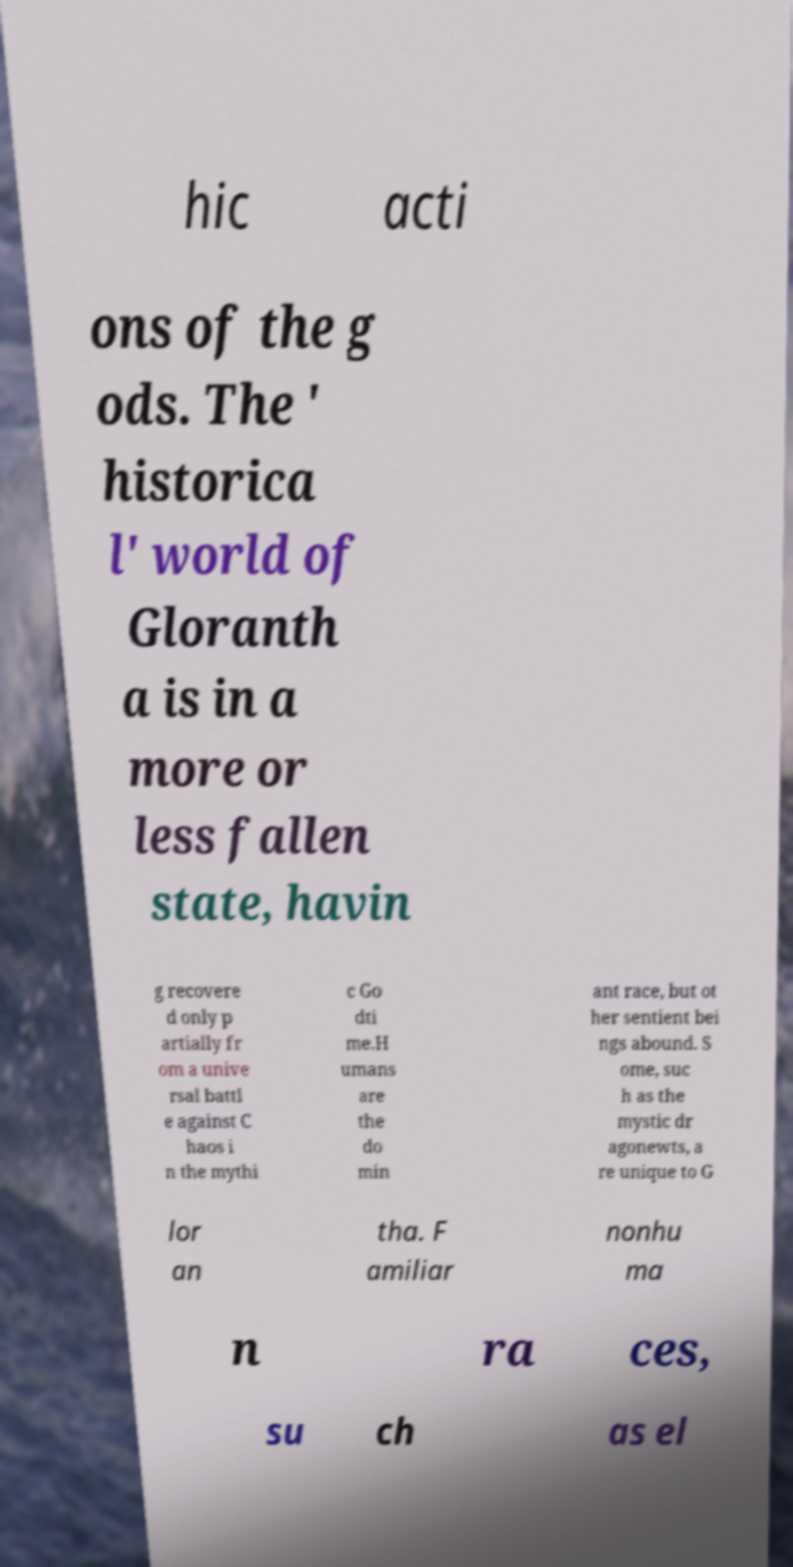Can you read and provide the text displayed in the image?This photo seems to have some interesting text. Can you extract and type it out for me? hic acti ons of the g ods. The ' historica l' world of Gloranth a is in a more or less fallen state, havin g recovere d only p artially fr om a unive rsal battl e against C haos i n the mythi c Go dti me.H umans are the do min ant race, but ot her sentient bei ngs abound. S ome, suc h as the mystic dr agonewts, a re unique to G lor an tha. F amiliar nonhu ma n ra ces, su ch as el 